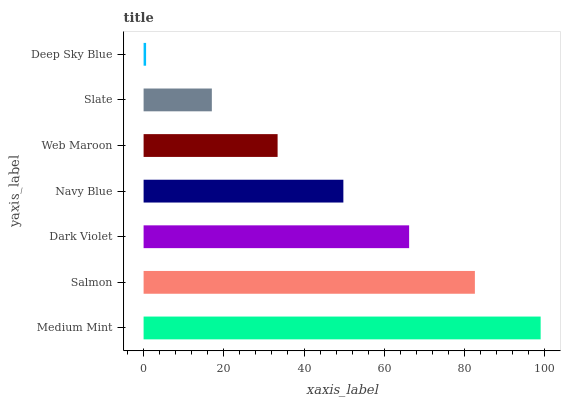Is Deep Sky Blue the minimum?
Answer yes or no. Yes. Is Medium Mint the maximum?
Answer yes or no. Yes. Is Salmon the minimum?
Answer yes or no. No. Is Salmon the maximum?
Answer yes or no. No. Is Medium Mint greater than Salmon?
Answer yes or no. Yes. Is Salmon less than Medium Mint?
Answer yes or no. Yes. Is Salmon greater than Medium Mint?
Answer yes or no. No. Is Medium Mint less than Salmon?
Answer yes or no. No. Is Navy Blue the high median?
Answer yes or no. Yes. Is Navy Blue the low median?
Answer yes or no. Yes. Is Slate the high median?
Answer yes or no. No. Is Web Maroon the low median?
Answer yes or no. No. 